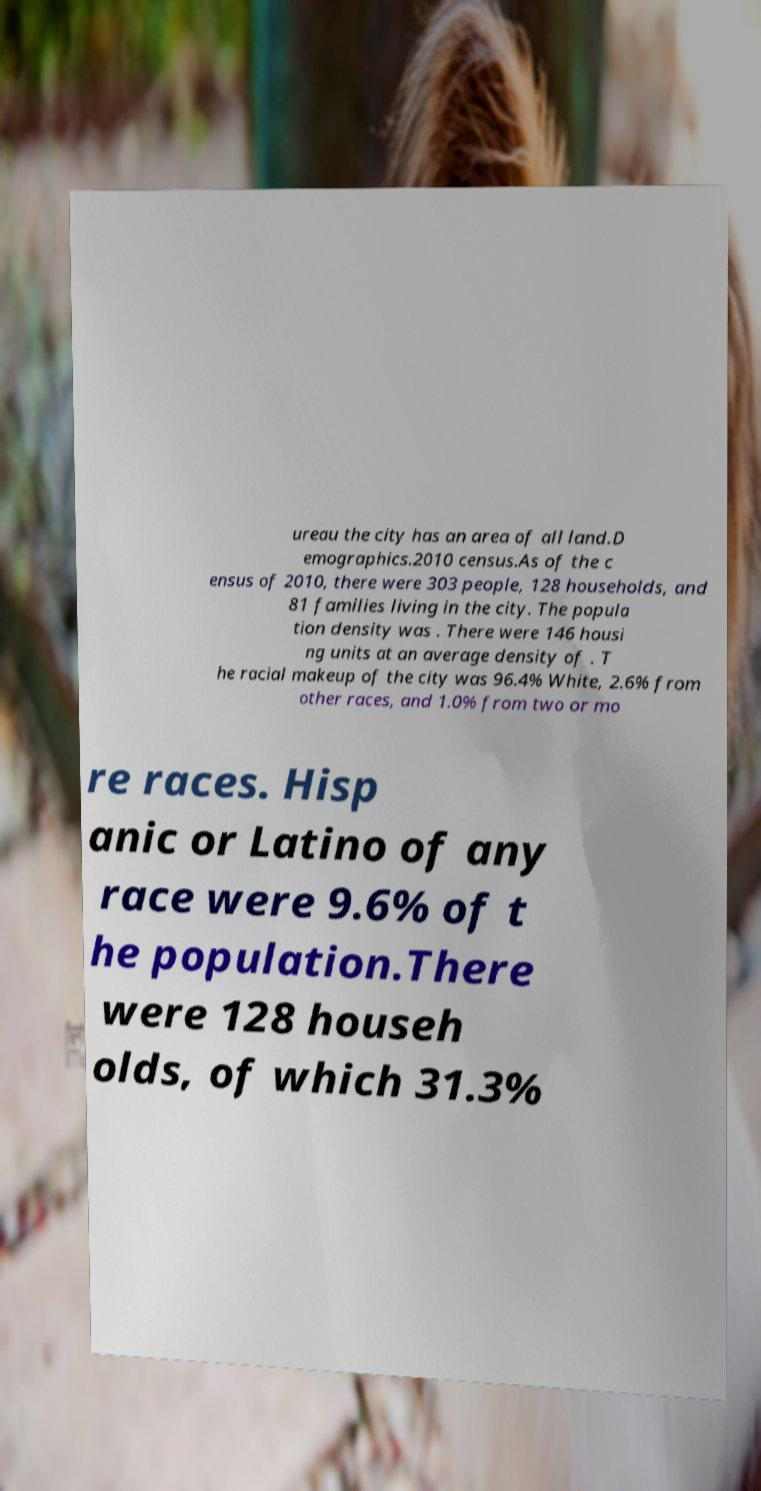Could you extract and type out the text from this image? ureau the city has an area of all land.D emographics.2010 census.As of the c ensus of 2010, there were 303 people, 128 households, and 81 families living in the city. The popula tion density was . There were 146 housi ng units at an average density of . T he racial makeup of the city was 96.4% White, 2.6% from other races, and 1.0% from two or mo re races. Hisp anic or Latino of any race were 9.6% of t he population.There were 128 househ olds, of which 31.3% 